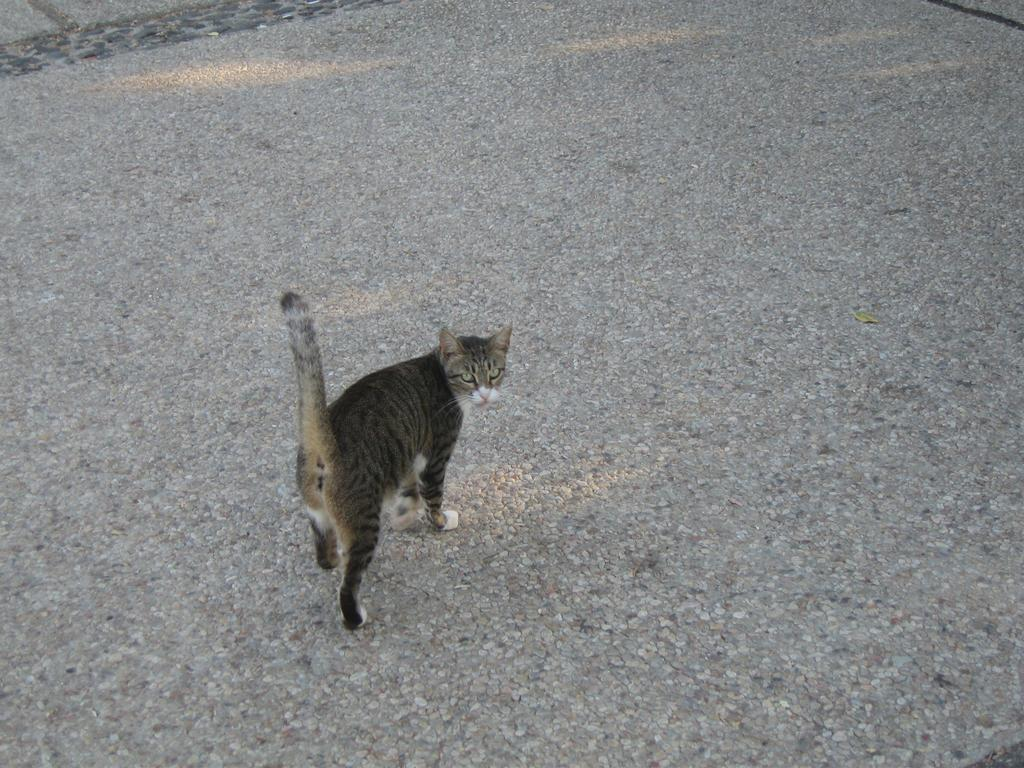What type of animal is in the image? There is a cat in the image. Where is the cat located in the image? The cat is on the ground. What type of zipper can be seen on the cat in the image? There is no zipper present on the cat in the image. 